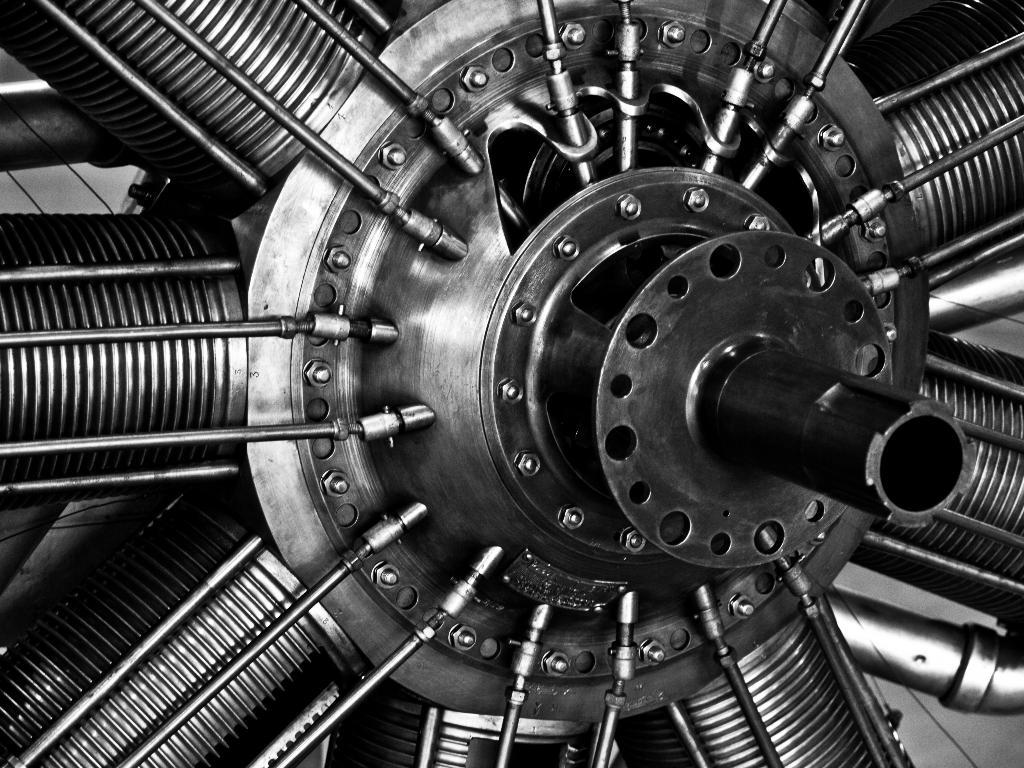What is the main object in the image? There is a wheel in the image. Can you describe the wheel in more detail? The wheel has spokes. What type of tax is being discussed in relation to the wheel in the image? There is no discussion of tax in relation to the wheel in the image. 